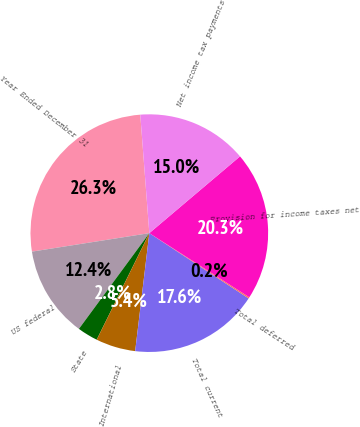<chart> <loc_0><loc_0><loc_500><loc_500><pie_chart><fcel>Year Ended December 31<fcel>US federal<fcel>State<fcel>International<fcel>Total current<fcel>Total deferred<fcel>Provision for income taxes net<fcel>Net income tax payments<nl><fcel>26.27%<fcel>12.42%<fcel>2.79%<fcel>5.4%<fcel>17.64%<fcel>0.18%<fcel>20.25%<fcel>15.03%<nl></chart> 